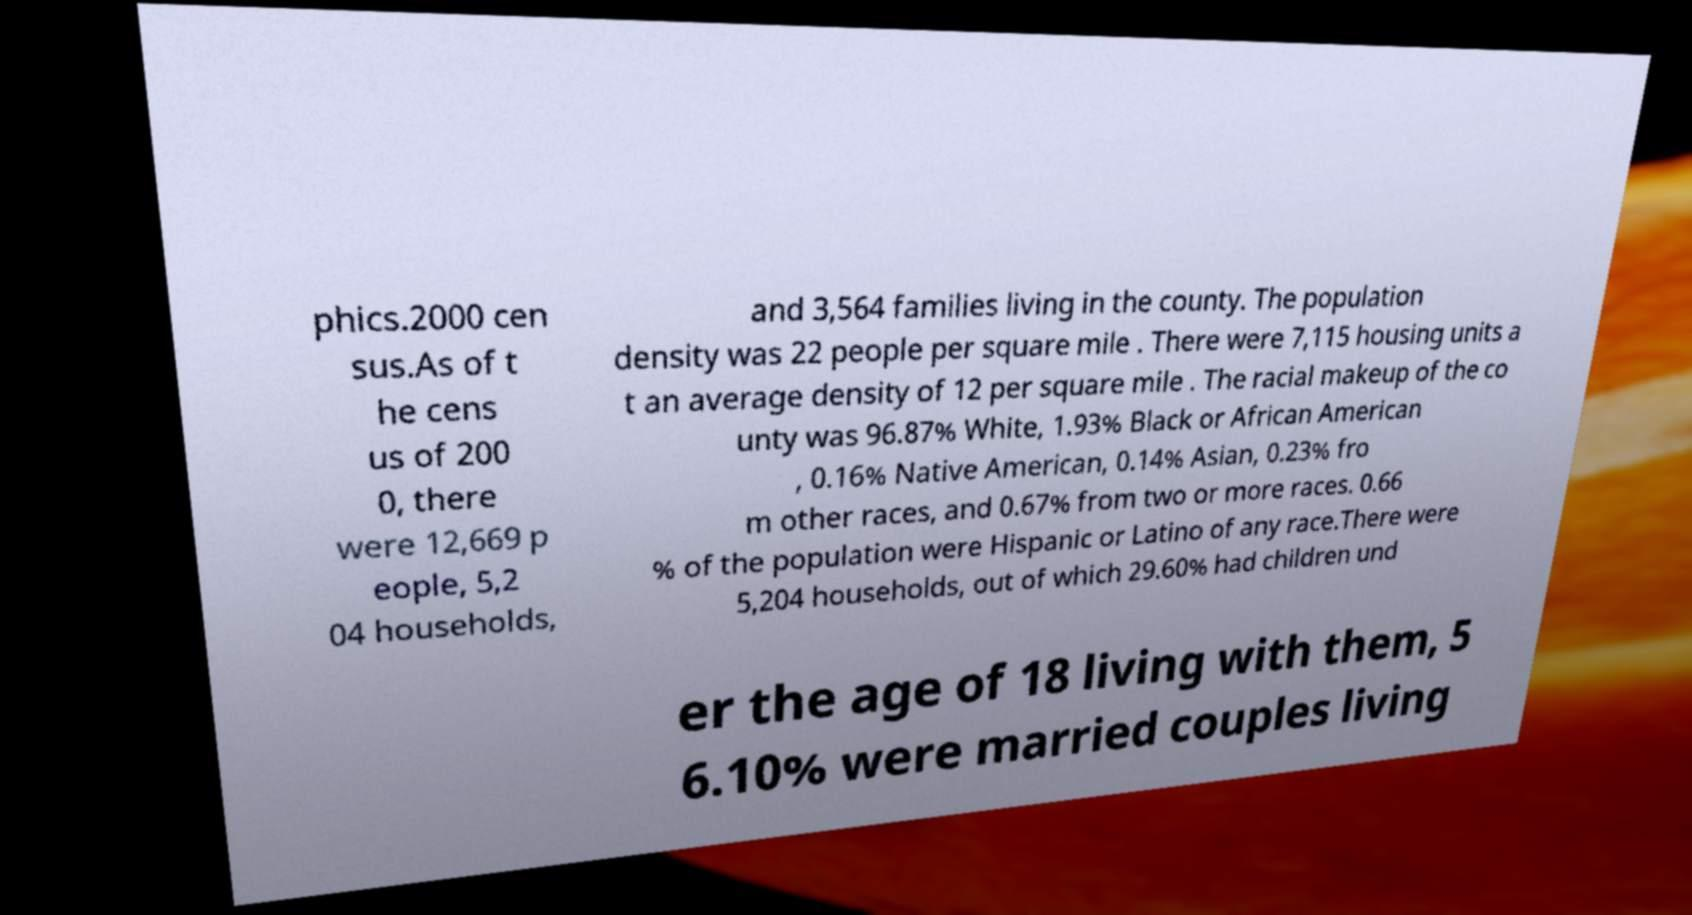I need the written content from this picture converted into text. Can you do that? phics.2000 cen sus.As of t he cens us of 200 0, there were 12,669 p eople, 5,2 04 households, and 3,564 families living in the county. The population density was 22 people per square mile . There were 7,115 housing units a t an average density of 12 per square mile . The racial makeup of the co unty was 96.87% White, 1.93% Black or African American , 0.16% Native American, 0.14% Asian, 0.23% fro m other races, and 0.67% from two or more races. 0.66 % of the population were Hispanic or Latino of any race.There were 5,204 households, out of which 29.60% had children und er the age of 18 living with them, 5 6.10% were married couples living 